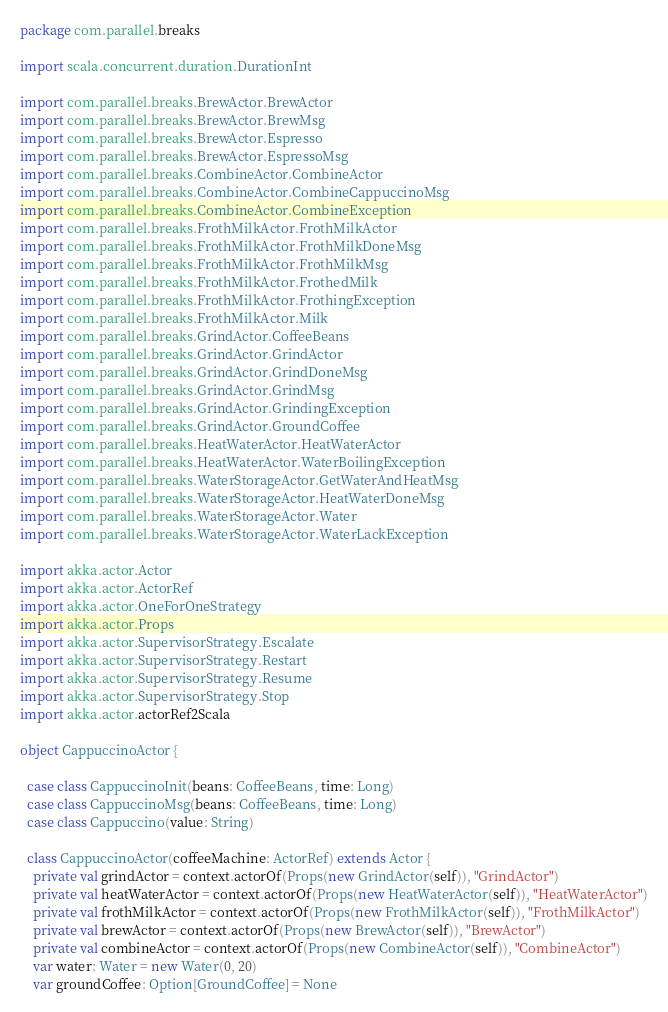Convert code to text. <code><loc_0><loc_0><loc_500><loc_500><_Scala_>package com.parallel.breaks

import scala.concurrent.duration.DurationInt

import com.parallel.breaks.BrewActor.BrewActor
import com.parallel.breaks.BrewActor.BrewMsg
import com.parallel.breaks.BrewActor.Espresso
import com.parallel.breaks.BrewActor.EspressoMsg
import com.parallel.breaks.CombineActor.CombineActor
import com.parallel.breaks.CombineActor.CombineCappuccinoMsg
import com.parallel.breaks.CombineActor.CombineException
import com.parallel.breaks.FrothMilkActor.FrothMilkActor
import com.parallel.breaks.FrothMilkActor.FrothMilkDoneMsg
import com.parallel.breaks.FrothMilkActor.FrothMilkMsg
import com.parallel.breaks.FrothMilkActor.FrothedMilk
import com.parallel.breaks.FrothMilkActor.FrothingException
import com.parallel.breaks.FrothMilkActor.Milk
import com.parallel.breaks.GrindActor.CoffeeBeans
import com.parallel.breaks.GrindActor.GrindActor
import com.parallel.breaks.GrindActor.GrindDoneMsg
import com.parallel.breaks.GrindActor.GrindMsg
import com.parallel.breaks.GrindActor.GrindingException
import com.parallel.breaks.GrindActor.GroundCoffee
import com.parallel.breaks.HeatWaterActor.HeatWaterActor
import com.parallel.breaks.HeatWaterActor.WaterBoilingException
import com.parallel.breaks.WaterStorageActor.GetWaterAndHeatMsg
import com.parallel.breaks.WaterStorageActor.HeatWaterDoneMsg
import com.parallel.breaks.WaterStorageActor.Water
import com.parallel.breaks.WaterStorageActor.WaterLackException

import akka.actor.Actor
import akka.actor.ActorRef
import akka.actor.OneForOneStrategy
import akka.actor.Props
import akka.actor.SupervisorStrategy.Escalate
import akka.actor.SupervisorStrategy.Restart
import akka.actor.SupervisorStrategy.Resume
import akka.actor.SupervisorStrategy.Stop
import akka.actor.actorRef2Scala

object CappuccinoActor {

  case class CappuccinoInit(beans: CoffeeBeans, time: Long)
  case class CappuccinoMsg(beans: CoffeeBeans, time: Long)
  case class Cappuccino(value: String)

  class CappuccinoActor(coffeeMachine: ActorRef) extends Actor {
    private val grindActor = context.actorOf(Props(new GrindActor(self)), "GrindActor")
    private val heatWaterActor = context.actorOf(Props(new HeatWaterActor(self)), "HeatWaterActor")
    private val frothMilkActor = context.actorOf(Props(new FrothMilkActor(self)), "FrothMilkActor")
    private val brewActor = context.actorOf(Props(new BrewActor(self)), "BrewActor")
    private val combineActor = context.actorOf(Props(new CombineActor(self)), "CombineActor")
    var water: Water = new Water(0, 20)
    var groundCoffee: Option[GroundCoffee] = None</code> 